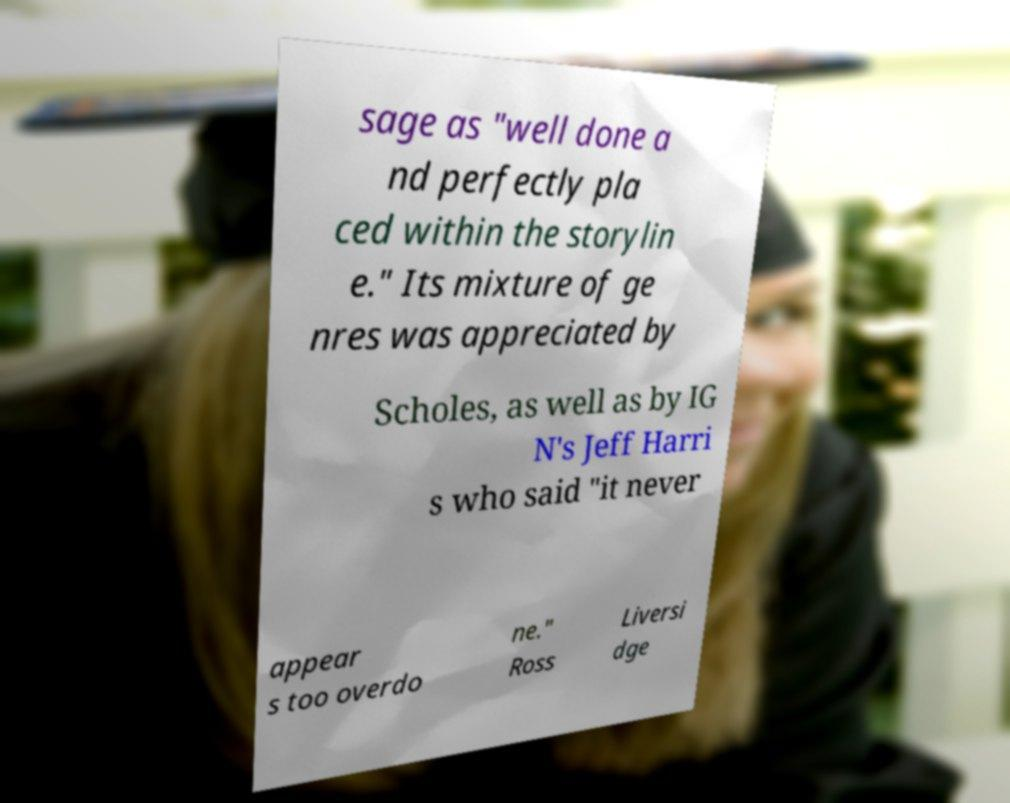Could you assist in decoding the text presented in this image and type it out clearly? sage as "well done a nd perfectly pla ced within the storylin e." Its mixture of ge nres was appreciated by Scholes, as well as by IG N's Jeff Harri s who said "it never appear s too overdo ne." Ross Liversi dge 